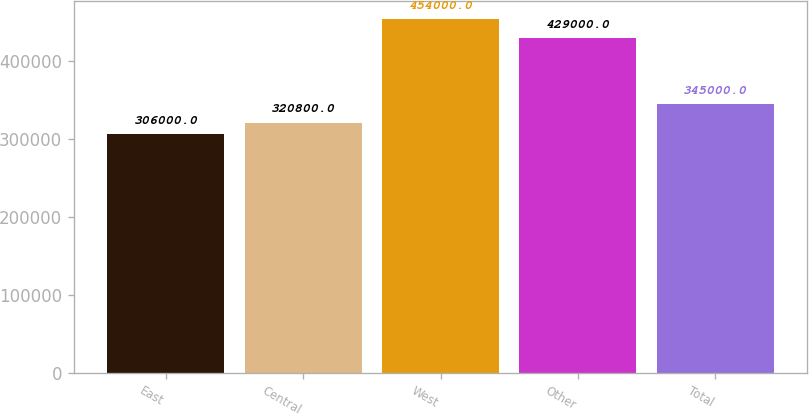Convert chart. <chart><loc_0><loc_0><loc_500><loc_500><bar_chart><fcel>East<fcel>Central<fcel>West<fcel>Other<fcel>Total<nl><fcel>306000<fcel>320800<fcel>454000<fcel>429000<fcel>345000<nl></chart> 